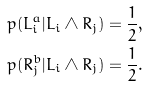Convert formula to latex. <formula><loc_0><loc_0><loc_500><loc_500>p ( L _ { i } ^ { a } | L _ { i } \wedge R _ { j } ) = \frac { 1 } { 2 } , \\ p ( R _ { j } ^ { b } | L _ { i } \wedge R _ { j } ) = \frac { 1 } { 2 } .</formula> 